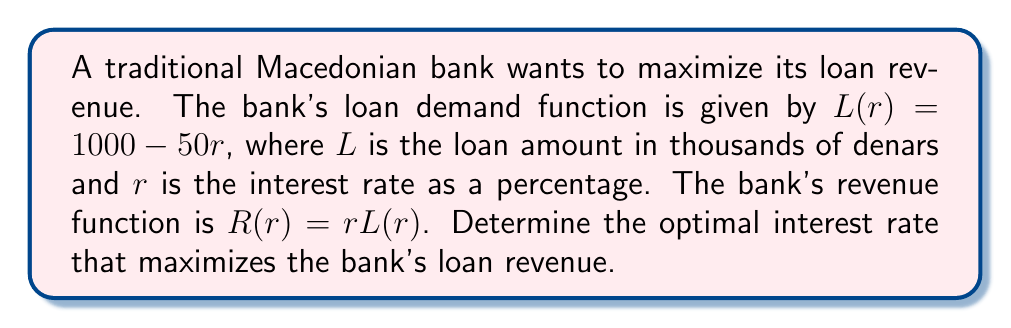Can you answer this question? To find the optimal interest rate, we need to follow these steps:

1. Express the revenue function in terms of $r$:
   $R(r) = r(1000 - 50r) = 1000r - 50r^2$

2. Find the derivative of the revenue function:
   $\frac{dR}{dr} = 1000 - 100r$

3. Set the derivative equal to zero to find the critical point:
   $1000 - 100r = 0$
   $100r = 1000$
   $r = 10$

4. Verify that this critical point is a maximum by checking the second derivative:
   $\frac{d^2R}{dr^2} = -100$

   Since the second derivative is negative, the critical point is a maximum.

5. Calculate the maximum revenue:
   $R(10) = 1000(10) - 50(10)^2 = 10000 - 5000 = 5000$

Therefore, the optimal interest rate is 10%, which yields a maximum revenue of 5,000,000 denars.
Answer: 10% 